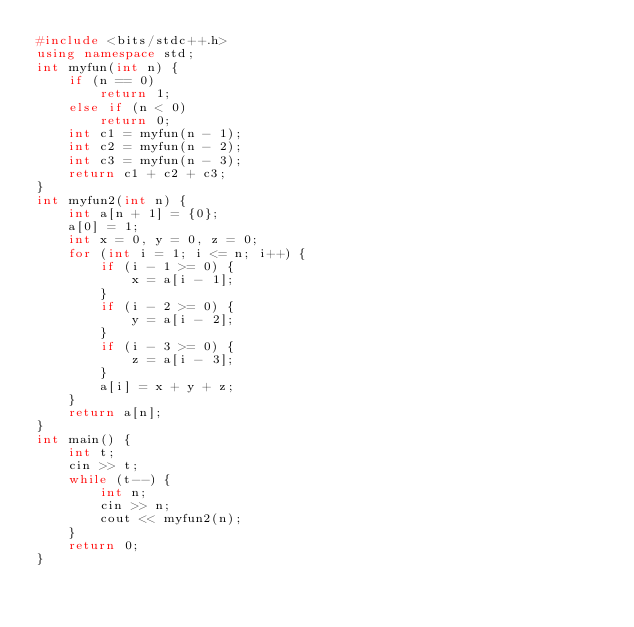Convert code to text. <code><loc_0><loc_0><loc_500><loc_500><_C++_>#include <bits/stdc++.h>
using namespace std;
int myfun(int n) {
    if (n == 0)
        return 1;
    else if (n < 0)
        return 0;
    int c1 = myfun(n - 1);
    int c2 = myfun(n - 2);
    int c3 = myfun(n - 3);
    return c1 + c2 + c3;
}
int myfun2(int n) {
    int a[n + 1] = {0};
    a[0] = 1;
    int x = 0, y = 0, z = 0;
    for (int i = 1; i <= n; i++) {
        if (i - 1 >= 0) {
            x = a[i - 1];
        }
        if (i - 2 >= 0) {
            y = a[i - 2];
        }
        if (i - 3 >= 0) {
            z = a[i - 3];
        }
        a[i] = x + y + z;
    }
    return a[n];
}
int main() {
    int t;
    cin >> t;
    while (t--) {
        int n;
        cin >> n;
        cout << myfun2(n);
    }
    return 0;
}</code> 